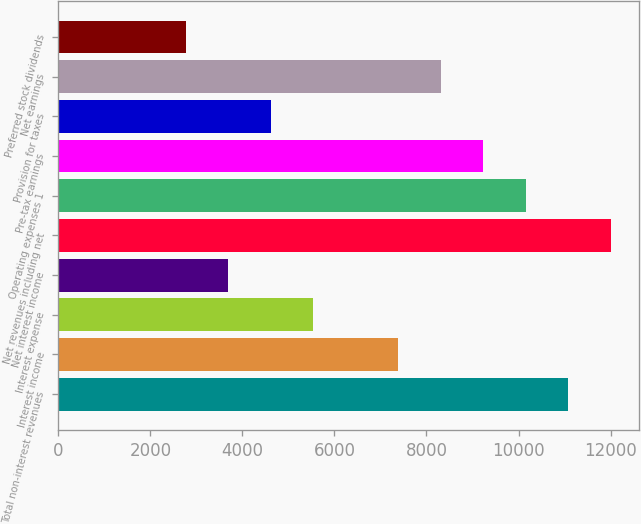Convert chart. <chart><loc_0><loc_0><loc_500><loc_500><bar_chart><fcel>Total non-interest revenues<fcel>Interest income<fcel>Interest expense<fcel>Net interest income<fcel>Net revenues including net<fcel>Operating expenses 1<fcel>Pre-tax earnings<fcel>Provision for taxes<fcel>Net earnings<fcel>Preferred stock dividends<nl><fcel>11083.1<fcel>7388.9<fcel>5541.8<fcel>3694.7<fcel>12006.6<fcel>10159.5<fcel>9236<fcel>4618.25<fcel>8312.45<fcel>2771.15<nl></chart> 